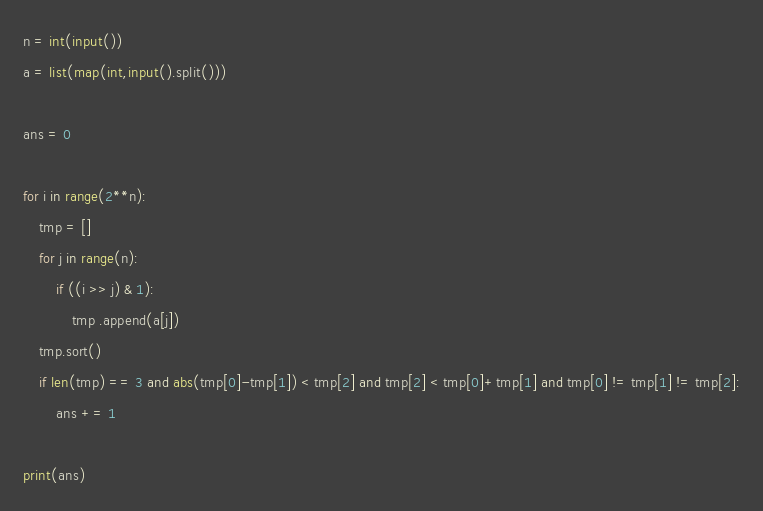<code> <loc_0><loc_0><loc_500><loc_500><_Python_>n = int(input())
a = list(map(int,input().split()))

ans = 0

for i in range(2**n):
    tmp = []
    for j in range(n):
        if ((i >> j) & 1):
            tmp .append(a[j])
    tmp.sort()
    if len(tmp) == 3 and abs(tmp[0]-tmp[1]) < tmp[2] and tmp[2] < tmp[0]+tmp[1] and tmp[0] != tmp[1] != tmp[2]:
        ans += 1

print(ans)</code> 